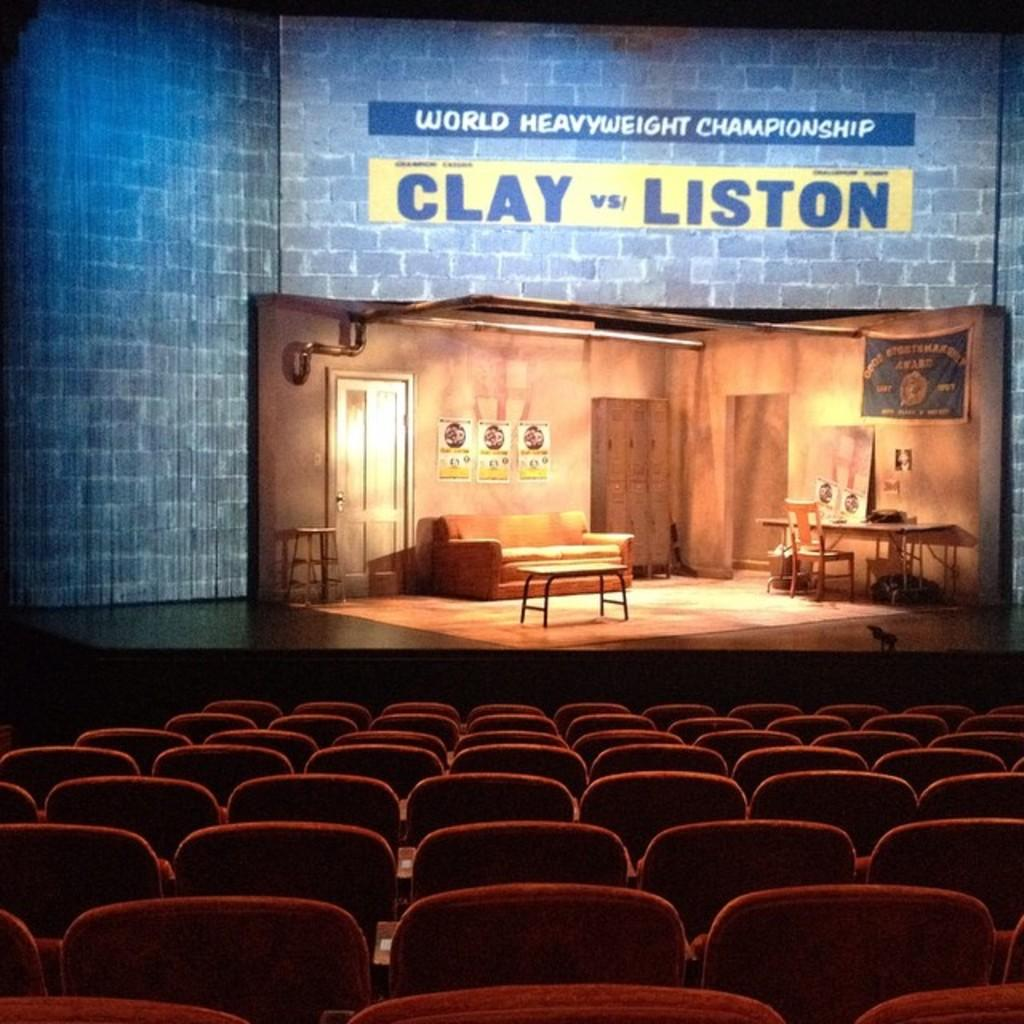What type of furniture is present in the image? There are chairs in the image. What can be seen in the background of the image? There is a stage, a couch, a door, and papers attached to the wall in the background of the image. What type of celery is being used to copy the papers on the wall? There is no celery present in the image, and the papers on the wall are not being copied. 